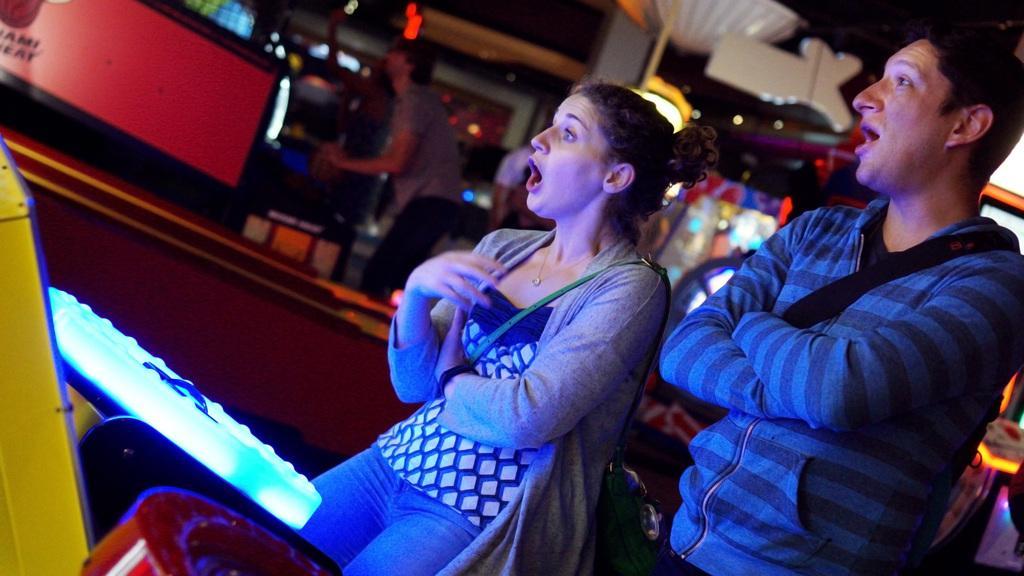Describe this image in one or two sentences. In this image I can see two people with different color dresses. In-front of these people I can see the gaming objects which are colorful. In the background I can see one more person and the lights. But it is blurry. 